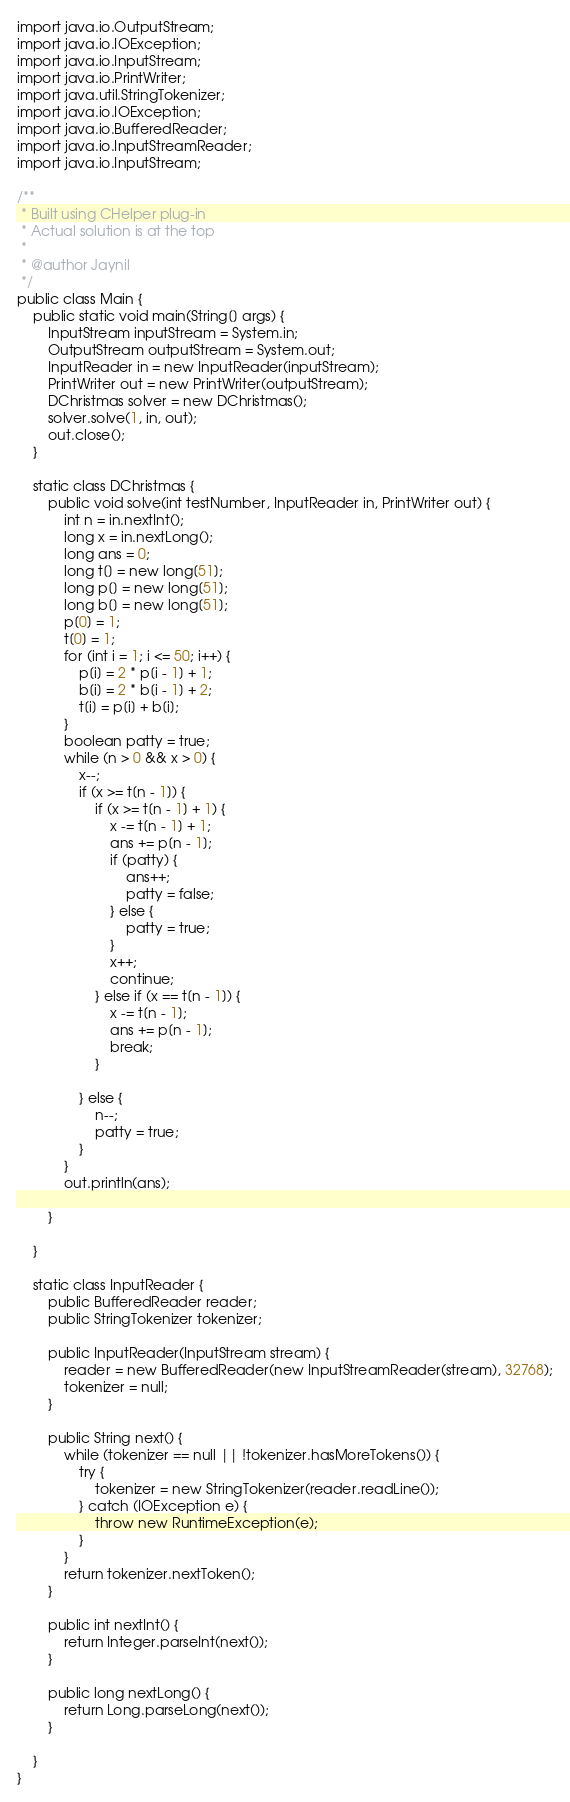Convert code to text. <code><loc_0><loc_0><loc_500><loc_500><_Java_>import java.io.OutputStream;
import java.io.IOException;
import java.io.InputStream;
import java.io.PrintWriter;
import java.util.StringTokenizer;
import java.io.IOException;
import java.io.BufferedReader;
import java.io.InputStreamReader;
import java.io.InputStream;

/**
 * Built using CHelper plug-in
 * Actual solution is at the top
 *
 * @author Jaynil
 */
public class Main {
    public static void main(String[] args) {
        InputStream inputStream = System.in;
        OutputStream outputStream = System.out;
        InputReader in = new InputReader(inputStream);
        PrintWriter out = new PrintWriter(outputStream);
        DChristmas solver = new DChristmas();
        solver.solve(1, in, out);
        out.close();
    }

    static class DChristmas {
        public void solve(int testNumber, InputReader in, PrintWriter out) {
            int n = in.nextInt();
            long x = in.nextLong();
            long ans = 0;
            long t[] = new long[51];
            long p[] = new long[51];
            long b[] = new long[51];
            p[0] = 1;
            t[0] = 1;
            for (int i = 1; i <= 50; i++) {
                p[i] = 2 * p[i - 1] + 1;
                b[i] = 2 * b[i - 1] + 2;
                t[i] = p[i] + b[i];
            }
            boolean patty = true;
            while (n > 0 && x > 0) {
                x--;
                if (x >= t[n - 1]) {
                    if (x >= t[n - 1] + 1) {
                        x -= t[n - 1] + 1;
                        ans += p[n - 1];
                        if (patty) {
                            ans++;
                            patty = false;
                        } else {
                            patty = true;
                        }
                        x++;
                        continue;
                    } else if (x == t[n - 1]) {
                        x -= t[n - 1];
                        ans += p[n - 1];
                        break;
                    }

                } else {
                    n--;
                    patty = true;
                }
            }
            out.println(ans);

        }

    }

    static class InputReader {
        public BufferedReader reader;
        public StringTokenizer tokenizer;

        public InputReader(InputStream stream) {
            reader = new BufferedReader(new InputStreamReader(stream), 32768);
            tokenizer = null;
        }

        public String next() {
            while (tokenizer == null || !tokenizer.hasMoreTokens()) {
                try {
                    tokenizer = new StringTokenizer(reader.readLine());
                } catch (IOException e) {
                    throw new RuntimeException(e);
                }
            }
            return tokenizer.nextToken();
        }

        public int nextInt() {
            return Integer.parseInt(next());
        }

        public long nextLong() {
            return Long.parseLong(next());
        }

    }
}

</code> 